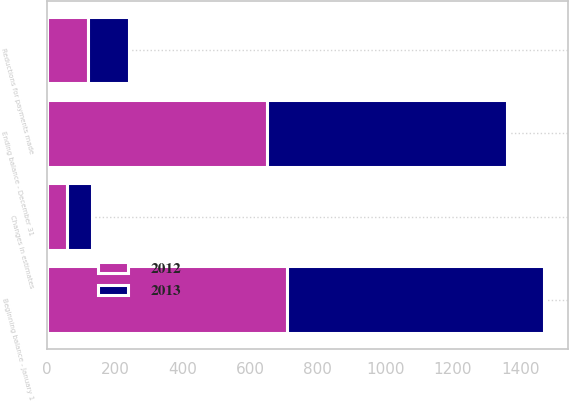Convert chart to OTSL. <chart><loc_0><loc_0><loc_500><loc_500><stacked_bar_chart><ecel><fcel>Beginning balance - January 1<fcel>Reductions for payments made<fcel>Changes in estimates<fcel>Ending balance - December 31<nl><fcel>2012<fcel>710<fcel>120<fcel>59<fcel>649<nl><fcel>2013<fcel>758<fcel>121<fcel>73<fcel>710<nl></chart> 